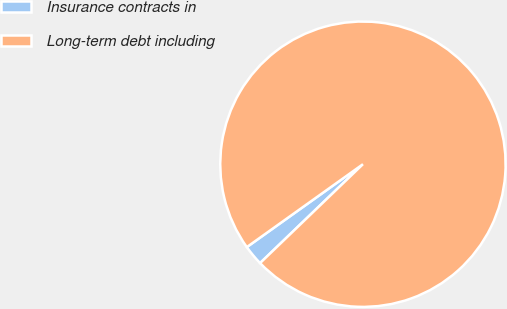Convert chart. <chart><loc_0><loc_0><loc_500><loc_500><pie_chart><fcel>Insurance contracts in<fcel>Long-term debt including<nl><fcel>2.32%<fcel>97.68%<nl></chart> 